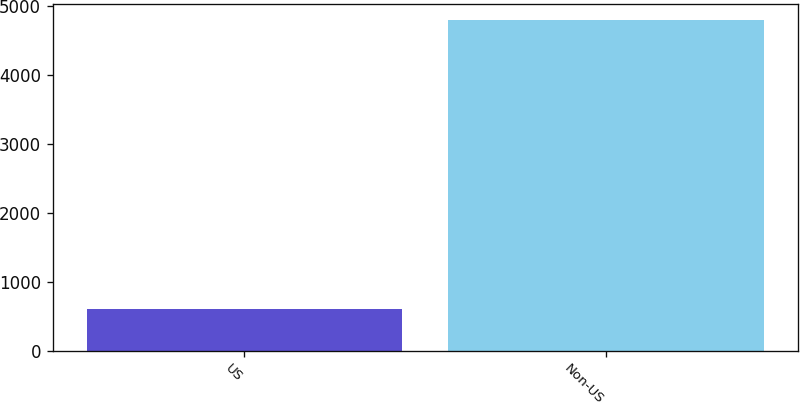Convert chart. <chart><loc_0><loc_0><loc_500><loc_500><bar_chart><fcel>US<fcel>Non-US<nl><fcel>603<fcel>4799<nl></chart> 